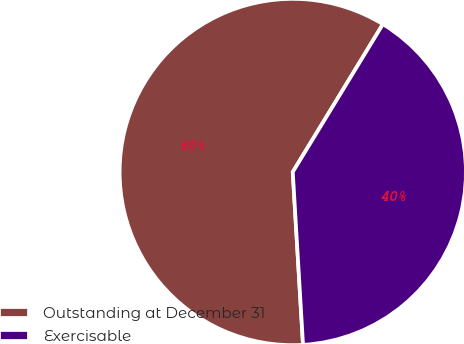Convert chart. <chart><loc_0><loc_0><loc_500><loc_500><pie_chart><fcel>Outstanding at December 31<fcel>Exercisable<nl><fcel>59.66%<fcel>40.34%<nl></chart> 